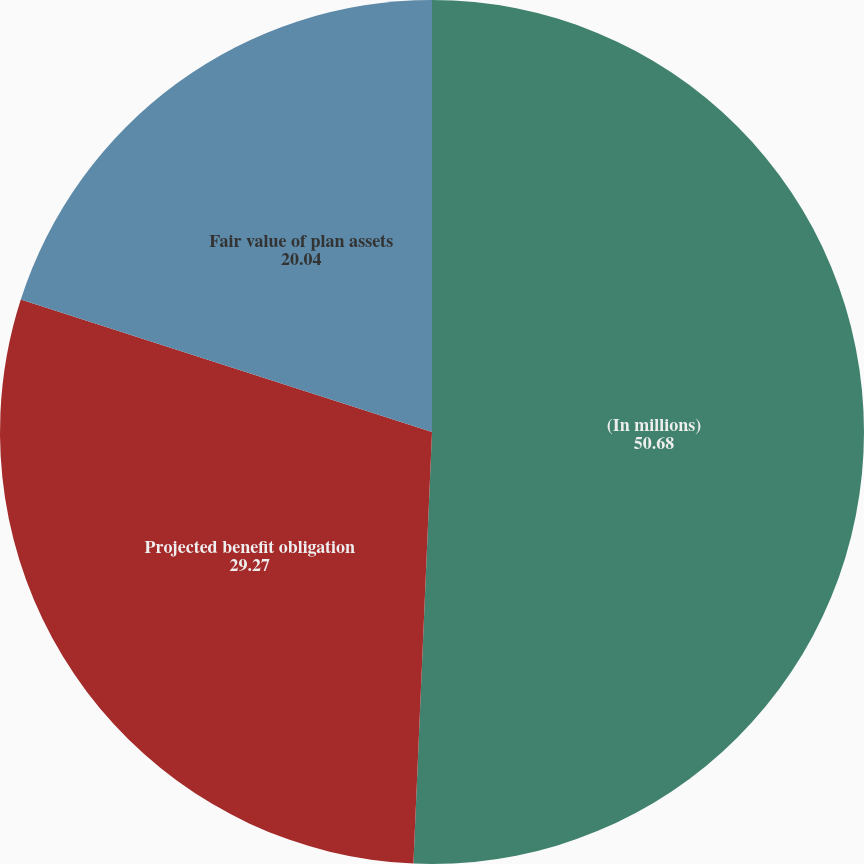Convert chart to OTSL. <chart><loc_0><loc_0><loc_500><loc_500><pie_chart><fcel>(In millions)<fcel>Projected benefit obligation<fcel>Fair value of plan assets<nl><fcel>50.68%<fcel>29.27%<fcel>20.04%<nl></chart> 